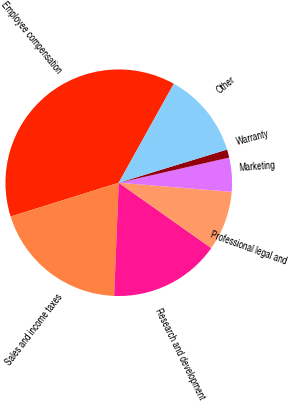Convert chart to OTSL. <chart><loc_0><loc_0><loc_500><loc_500><pie_chart><fcel>Employee compensation<fcel>Sales and income taxes<fcel>Research and development<fcel>Professional legal and<fcel>Marketing<fcel>Warranty<fcel>Other<nl><fcel>37.9%<fcel>19.53%<fcel>15.86%<fcel>8.51%<fcel>4.84%<fcel>1.17%<fcel>12.19%<nl></chart> 